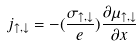Convert formula to latex. <formula><loc_0><loc_0><loc_500><loc_500>j _ { \uparrow , \downarrow } = - ( \frac { \sigma _ { \uparrow , \downarrow } } { e } ) \frac { \partial \mu _ { \uparrow , \downarrow } } { \partial x }</formula> 